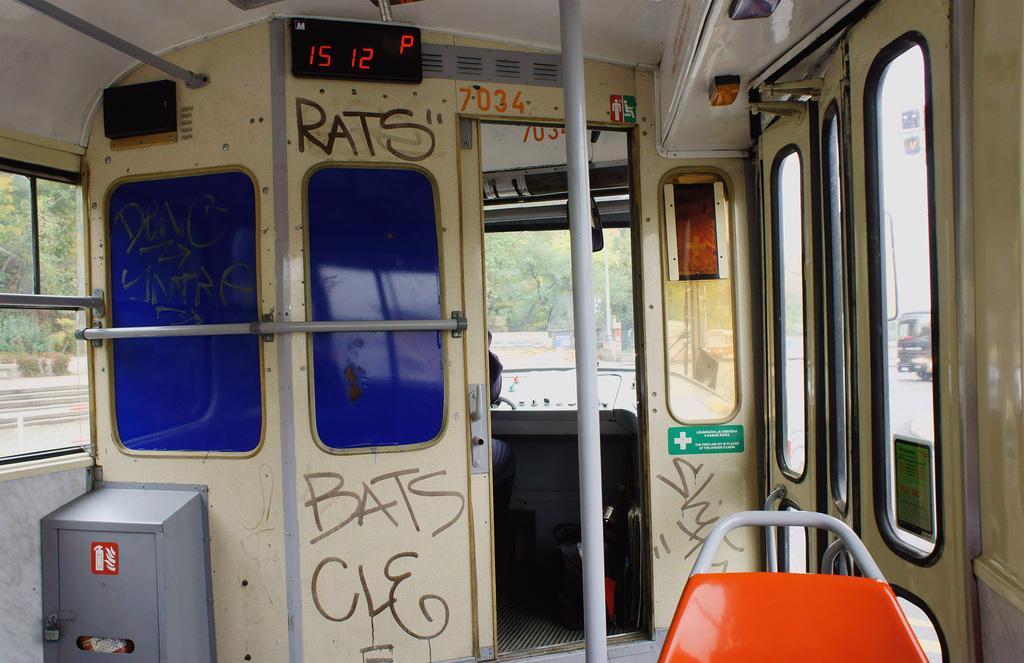In one or two sentences, can you explain what this image depicts? In this image we can see inside of a vehicle. There are doors, windows, iron rods. Also there is a box and a chair. On the wall something is written. And there is a screen. Through the windows we can see trees and another vehicle. 